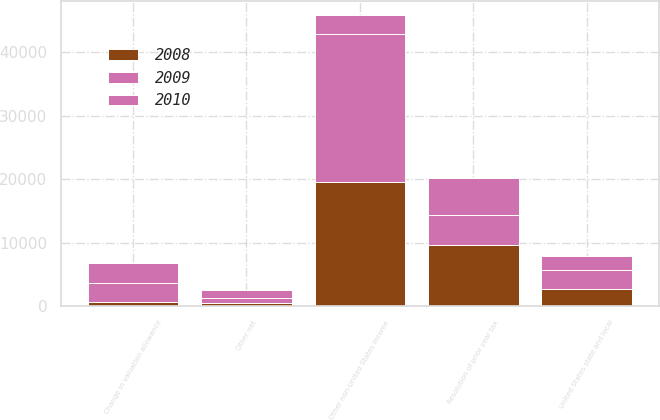Convert chart. <chart><loc_0><loc_0><loc_500><loc_500><stacked_bar_chart><ecel><fcel>United States state and local<fcel>Change in valuation allowance<fcel>Other non-United States income<fcel>Resolution of prior year tax<fcel>Other net<nl><fcel>2010<fcel>2115<fcel>3229<fcel>2999<fcel>5757<fcel>1245<nl><fcel>2008<fcel>2768<fcel>598<fcel>19499<fcel>9681<fcel>512<nl><fcel>2009<fcel>2966<fcel>3032<fcel>23357<fcel>4738<fcel>815<nl></chart> 